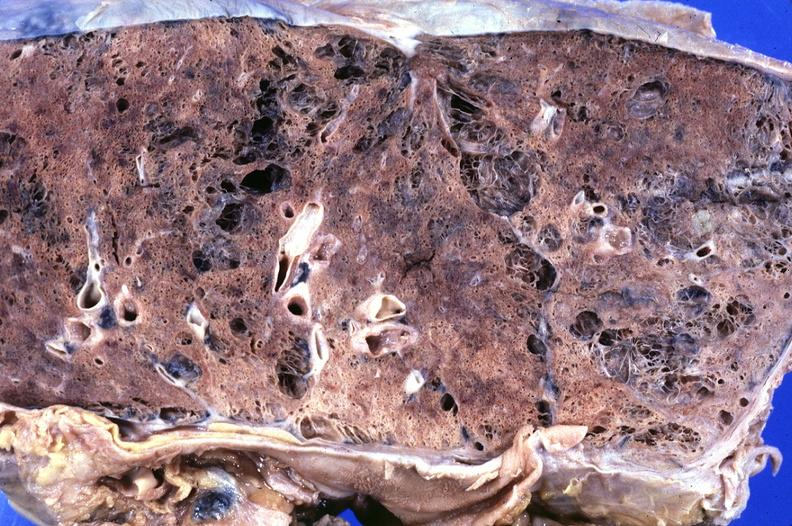what does this image show?
Answer the question using a single word or phrase. Lung 